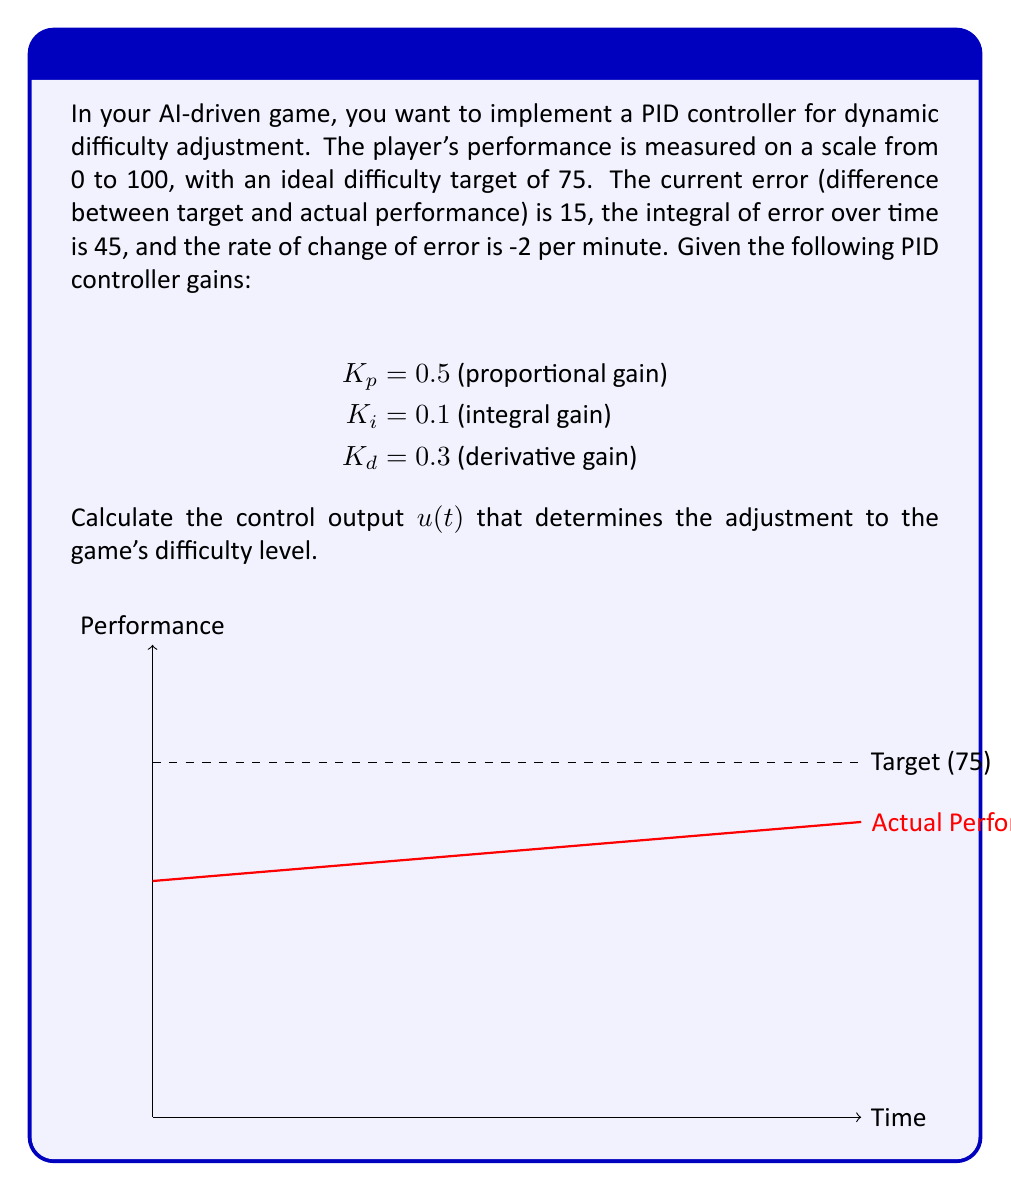Can you solve this math problem? To solve this problem, we'll use the PID controller equation:

$$u(t) = K_p e(t) + K_i \int e(t) dt + K_d \frac{de(t)}{dt}$$

Where:
$u(t)$ is the control output
$e(t)$ is the error
$\int e(t) dt$ is the integral of error over time
$\frac{de(t)}{dt}$ is the rate of change of error

Given:
- Current error $e(t) = 15$
- Integral of error $\int e(t) dt = 45$
- Rate of change of error $\frac{de(t)}{dt} = -2$ per minute
- $K_p = 0.5$, $K_i = 0.1$, $K_d = 0.3$

Let's calculate each term:

1. Proportional term: $K_p e(t) = 0.5 \times 15 = 7.5$
2. Integral term: $K_i \int e(t) dt = 0.1 \times 45 = 4.5$
3. Derivative term: $K_d \frac{de(t)}{dt} = 0.3 \times (-2) = -0.6$

Now, sum up all terms:

$$u(t) = 7.5 + 4.5 + (-0.6) = 11.4$$

This value represents the adjustment to be made to the game's difficulty level.
Answer: $u(t) = 11.4$ 